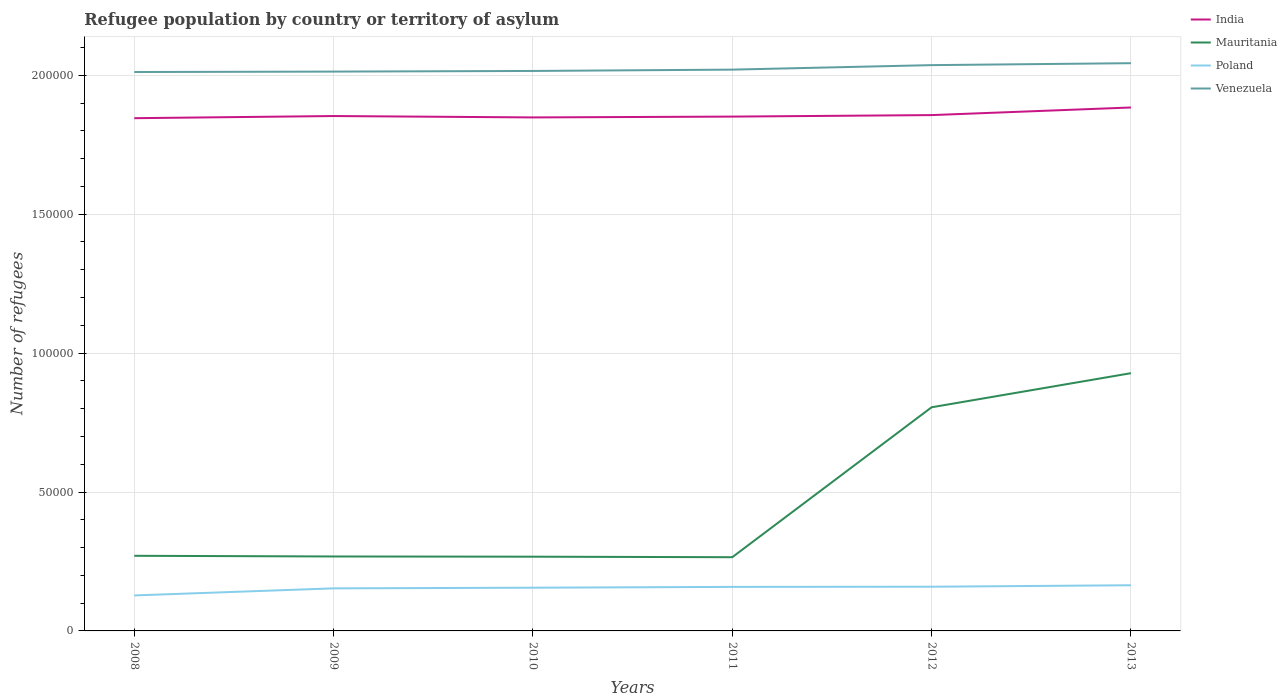How many different coloured lines are there?
Your response must be concise. 4. Is the number of lines equal to the number of legend labels?
Provide a succinct answer. Yes. Across all years, what is the maximum number of refugees in Poland?
Ensure brevity in your answer.  1.28e+04. What is the total number of refugees in India in the graph?
Offer a terse response. -278. What is the difference between the highest and the second highest number of refugees in Venezuela?
Ensure brevity in your answer.  3179. How many years are there in the graph?
Ensure brevity in your answer.  6. Does the graph contain any zero values?
Offer a terse response. No. Where does the legend appear in the graph?
Provide a short and direct response. Top right. How many legend labels are there?
Ensure brevity in your answer.  4. How are the legend labels stacked?
Make the answer very short. Vertical. What is the title of the graph?
Ensure brevity in your answer.  Refugee population by country or territory of asylum. What is the label or title of the Y-axis?
Keep it short and to the point. Number of refugees. What is the Number of refugees of India in 2008?
Provide a succinct answer. 1.85e+05. What is the Number of refugees of Mauritania in 2008?
Keep it short and to the point. 2.70e+04. What is the Number of refugees in Poland in 2008?
Keep it short and to the point. 1.28e+04. What is the Number of refugees of Venezuela in 2008?
Provide a short and direct response. 2.01e+05. What is the Number of refugees of India in 2009?
Make the answer very short. 1.85e+05. What is the Number of refugees of Mauritania in 2009?
Your response must be concise. 2.68e+04. What is the Number of refugees of Poland in 2009?
Provide a short and direct response. 1.53e+04. What is the Number of refugees of Venezuela in 2009?
Keep it short and to the point. 2.01e+05. What is the Number of refugees in India in 2010?
Keep it short and to the point. 1.85e+05. What is the Number of refugees in Mauritania in 2010?
Offer a terse response. 2.67e+04. What is the Number of refugees of Poland in 2010?
Your answer should be compact. 1.56e+04. What is the Number of refugees of Venezuela in 2010?
Give a very brief answer. 2.02e+05. What is the Number of refugees of India in 2011?
Offer a very short reply. 1.85e+05. What is the Number of refugees of Mauritania in 2011?
Keep it short and to the point. 2.65e+04. What is the Number of refugees of Poland in 2011?
Offer a terse response. 1.58e+04. What is the Number of refugees in Venezuela in 2011?
Ensure brevity in your answer.  2.02e+05. What is the Number of refugees in India in 2012?
Provide a short and direct response. 1.86e+05. What is the Number of refugees in Mauritania in 2012?
Keep it short and to the point. 8.05e+04. What is the Number of refugees in Poland in 2012?
Make the answer very short. 1.59e+04. What is the Number of refugees in Venezuela in 2012?
Keep it short and to the point. 2.04e+05. What is the Number of refugees in India in 2013?
Your answer should be very brief. 1.88e+05. What is the Number of refugees in Mauritania in 2013?
Give a very brief answer. 9.28e+04. What is the Number of refugees of Poland in 2013?
Make the answer very short. 1.64e+04. What is the Number of refugees in Venezuela in 2013?
Offer a very short reply. 2.04e+05. Across all years, what is the maximum Number of refugees in India?
Ensure brevity in your answer.  1.88e+05. Across all years, what is the maximum Number of refugees of Mauritania?
Your answer should be compact. 9.28e+04. Across all years, what is the maximum Number of refugees in Poland?
Your answer should be very brief. 1.64e+04. Across all years, what is the maximum Number of refugees in Venezuela?
Ensure brevity in your answer.  2.04e+05. Across all years, what is the minimum Number of refugees of India?
Provide a succinct answer. 1.85e+05. Across all years, what is the minimum Number of refugees in Mauritania?
Provide a succinct answer. 2.65e+04. Across all years, what is the minimum Number of refugees in Poland?
Keep it short and to the point. 1.28e+04. Across all years, what is the minimum Number of refugees in Venezuela?
Your response must be concise. 2.01e+05. What is the total Number of refugees in India in the graph?
Keep it short and to the point. 1.11e+06. What is the total Number of refugees in Mauritania in the graph?
Offer a terse response. 2.80e+05. What is the total Number of refugees of Poland in the graph?
Your answer should be very brief. 9.18e+04. What is the total Number of refugees in Venezuela in the graph?
Your answer should be very brief. 1.21e+06. What is the difference between the Number of refugees of India in 2008 and that in 2009?
Ensure brevity in your answer.  -780. What is the difference between the Number of refugees in Mauritania in 2008 and that in 2009?
Offer a very short reply. 246. What is the difference between the Number of refugees in Poland in 2008 and that in 2009?
Ensure brevity in your answer.  -2546. What is the difference between the Number of refugees of Venezuela in 2008 and that in 2009?
Offer a very short reply. -152. What is the difference between the Number of refugees of India in 2008 and that in 2010?
Ensure brevity in your answer.  -278. What is the difference between the Number of refugees in Mauritania in 2008 and that in 2010?
Provide a succinct answer. 324. What is the difference between the Number of refugees in Poland in 2008 and that in 2010?
Provide a succinct answer. -2781. What is the difference between the Number of refugees of Venezuela in 2008 and that in 2010?
Your answer should be compact. -386. What is the difference between the Number of refugees of India in 2008 and that in 2011?
Provide a short and direct response. -575. What is the difference between the Number of refugees in Mauritania in 2008 and that in 2011?
Your response must be concise. 506. What is the difference between the Number of refugees of Poland in 2008 and that in 2011?
Your response must be concise. -3073. What is the difference between the Number of refugees of Venezuela in 2008 and that in 2011?
Provide a succinct answer. -861. What is the difference between the Number of refugees of India in 2008 and that in 2012?
Provide a short and direct response. -1113. What is the difference between the Number of refugees of Mauritania in 2008 and that in 2012?
Give a very brief answer. -5.35e+04. What is the difference between the Number of refugees in Poland in 2008 and that in 2012?
Make the answer very short. -3137. What is the difference between the Number of refugees of Venezuela in 2008 and that in 2012?
Keep it short and to the point. -2483. What is the difference between the Number of refugees in India in 2008 and that in 2013?
Keep it short and to the point. -3852. What is the difference between the Number of refugees in Mauritania in 2008 and that in 2013?
Keep it short and to the point. -6.57e+04. What is the difference between the Number of refugees of Poland in 2008 and that in 2013?
Keep it short and to the point. -3664. What is the difference between the Number of refugees in Venezuela in 2008 and that in 2013?
Offer a very short reply. -3179. What is the difference between the Number of refugees of India in 2009 and that in 2010?
Provide a succinct answer. 502. What is the difference between the Number of refugees of Mauritania in 2009 and that in 2010?
Your answer should be compact. 78. What is the difference between the Number of refugees of Poland in 2009 and that in 2010?
Offer a terse response. -235. What is the difference between the Number of refugees of Venezuela in 2009 and that in 2010?
Your response must be concise. -234. What is the difference between the Number of refugees in India in 2009 and that in 2011?
Make the answer very short. 205. What is the difference between the Number of refugees in Mauritania in 2009 and that in 2011?
Offer a terse response. 260. What is the difference between the Number of refugees in Poland in 2009 and that in 2011?
Offer a very short reply. -527. What is the difference between the Number of refugees in Venezuela in 2009 and that in 2011?
Offer a very short reply. -709. What is the difference between the Number of refugees in India in 2009 and that in 2012?
Keep it short and to the point. -333. What is the difference between the Number of refugees of Mauritania in 2009 and that in 2012?
Provide a succinct answer. -5.37e+04. What is the difference between the Number of refugees in Poland in 2009 and that in 2012?
Offer a terse response. -591. What is the difference between the Number of refugees in Venezuela in 2009 and that in 2012?
Make the answer very short. -2331. What is the difference between the Number of refugees of India in 2009 and that in 2013?
Offer a very short reply. -3072. What is the difference between the Number of refugees of Mauritania in 2009 and that in 2013?
Offer a very short reply. -6.60e+04. What is the difference between the Number of refugees of Poland in 2009 and that in 2013?
Offer a terse response. -1118. What is the difference between the Number of refugees in Venezuela in 2009 and that in 2013?
Your response must be concise. -3027. What is the difference between the Number of refugees of India in 2010 and that in 2011?
Your answer should be compact. -297. What is the difference between the Number of refugees in Mauritania in 2010 and that in 2011?
Make the answer very short. 182. What is the difference between the Number of refugees in Poland in 2010 and that in 2011?
Your answer should be very brief. -292. What is the difference between the Number of refugees of Venezuela in 2010 and that in 2011?
Give a very brief answer. -475. What is the difference between the Number of refugees in India in 2010 and that in 2012?
Offer a very short reply. -835. What is the difference between the Number of refugees of Mauritania in 2010 and that in 2012?
Ensure brevity in your answer.  -5.38e+04. What is the difference between the Number of refugees of Poland in 2010 and that in 2012?
Provide a succinct answer. -356. What is the difference between the Number of refugees in Venezuela in 2010 and that in 2012?
Give a very brief answer. -2097. What is the difference between the Number of refugees of India in 2010 and that in 2013?
Give a very brief answer. -3574. What is the difference between the Number of refugees in Mauritania in 2010 and that in 2013?
Keep it short and to the point. -6.60e+04. What is the difference between the Number of refugees in Poland in 2010 and that in 2013?
Your answer should be very brief. -883. What is the difference between the Number of refugees in Venezuela in 2010 and that in 2013?
Your answer should be compact. -2793. What is the difference between the Number of refugees in India in 2011 and that in 2012?
Your response must be concise. -538. What is the difference between the Number of refugees in Mauritania in 2011 and that in 2012?
Offer a terse response. -5.40e+04. What is the difference between the Number of refugees in Poland in 2011 and that in 2012?
Keep it short and to the point. -64. What is the difference between the Number of refugees of Venezuela in 2011 and that in 2012?
Provide a succinct answer. -1622. What is the difference between the Number of refugees in India in 2011 and that in 2013?
Your response must be concise. -3277. What is the difference between the Number of refugees in Mauritania in 2011 and that in 2013?
Provide a short and direct response. -6.62e+04. What is the difference between the Number of refugees in Poland in 2011 and that in 2013?
Ensure brevity in your answer.  -591. What is the difference between the Number of refugees of Venezuela in 2011 and that in 2013?
Give a very brief answer. -2318. What is the difference between the Number of refugees in India in 2012 and that in 2013?
Give a very brief answer. -2739. What is the difference between the Number of refugees of Mauritania in 2012 and that in 2013?
Give a very brief answer. -1.23e+04. What is the difference between the Number of refugees of Poland in 2012 and that in 2013?
Ensure brevity in your answer.  -527. What is the difference between the Number of refugees of Venezuela in 2012 and that in 2013?
Offer a terse response. -696. What is the difference between the Number of refugees of India in 2008 and the Number of refugees of Mauritania in 2009?
Provide a succinct answer. 1.58e+05. What is the difference between the Number of refugees in India in 2008 and the Number of refugees in Poland in 2009?
Offer a terse response. 1.69e+05. What is the difference between the Number of refugees in India in 2008 and the Number of refugees in Venezuela in 2009?
Make the answer very short. -1.68e+04. What is the difference between the Number of refugees of Mauritania in 2008 and the Number of refugees of Poland in 2009?
Give a very brief answer. 1.17e+04. What is the difference between the Number of refugees in Mauritania in 2008 and the Number of refugees in Venezuela in 2009?
Your response must be concise. -1.74e+05. What is the difference between the Number of refugees of Poland in 2008 and the Number of refugees of Venezuela in 2009?
Offer a very short reply. -1.89e+05. What is the difference between the Number of refugees of India in 2008 and the Number of refugees of Mauritania in 2010?
Your answer should be very brief. 1.58e+05. What is the difference between the Number of refugees of India in 2008 and the Number of refugees of Poland in 2010?
Your answer should be compact. 1.69e+05. What is the difference between the Number of refugees of India in 2008 and the Number of refugees of Venezuela in 2010?
Give a very brief answer. -1.70e+04. What is the difference between the Number of refugees of Mauritania in 2008 and the Number of refugees of Poland in 2010?
Provide a short and direct response. 1.15e+04. What is the difference between the Number of refugees in Mauritania in 2008 and the Number of refugees in Venezuela in 2010?
Your answer should be compact. -1.75e+05. What is the difference between the Number of refugees of Poland in 2008 and the Number of refugees of Venezuela in 2010?
Keep it short and to the point. -1.89e+05. What is the difference between the Number of refugees of India in 2008 and the Number of refugees of Mauritania in 2011?
Give a very brief answer. 1.58e+05. What is the difference between the Number of refugees in India in 2008 and the Number of refugees in Poland in 2011?
Ensure brevity in your answer.  1.69e+05. What is the difference between the Number of refugees in India in 2008 and the Number of refugees in Venezuela in 2011?
Offer a very short reply. -1.75e+04. What is the difference between the Number of refugees in Mauritania in 2008 and the Number of refugees in Poland in 2011?
Ensure brevity in your answer.  1.12e+04. What is the difference between the Number of refugees in Mauritania in 2008 and the Number of refugees in Venezuela in 2011?
Your response must be concise. -1.75e+05. What is the difference between the Number of refugees of Poland in 2008 and the Number of refugees of Venezuela in 2011?
Ensure brevity in your answer.  -1.89e+05. What is the difference between the Number of refugees of India in 2008 and the Number of refugees of Mauritania in 2012?
Provide a succinct answer. 1.04e+05. What is the difference between the Number of refugees of India in 2008 and the Number of refugees of Poland in 2012?
Keep it short and to the point. 1.69e+05. What is the difference between the Number of refugees of India in 2008 and the Number of refugees of Venezuela in 2012?
Your answer should be compact. -1.91e+04. What is the difference between the Number of refugees in Mauritania in 2008 and the Number of refugees in Poland in 2012?
Your answer should be very brief. 1.11e+04. What is the difference between the Number of refugees in Mauritania in 2008 and the Number of refugees in Venezuela in 2012?
Your answer should be very brief. -1.77e+05. What is the difference between the Number of refugees of Poland in 2008 and the Number of refugees of Venezuela in 2012?
Make the answer very short. -1.91e+05. What is the difference between the Number of refugees of India in 2008 and the Number of refugees of Mauritania in 2013?
Offer a terse response. 9.18e+04. What is the difference between the Number of refugees of India in 2008 and the Number of refugees of Poland in 2013?
Ensure brevity in your answer.  1.68e+05. What is the difference between the Number of refugees in India in 2008 and the Number of refugees in Venezuela in 2013?
Provide a succinct answer. -1.98e+04. What is the difference between the Number of refugees of Mauritania in 2008 and the Number of refugees of Poland in 2013?
Your answer should be very brief. 1.06e+04. What is the difference between the Number of refugees in Mauritania in 2008 and the Number of refugees in Venezuela in 2013?
Offer a terse response. -1.77e+05. What is the difference between the Number of refugees in Poland in 2008 and the Number of refugees in Venezuela in 2013?
Keep it short and to the point. -1.92e+05. What is the difference between the Number of refugees in India in 2009 and the Number of refugees in Mauritania in 2010?
Give a very brief answer. 1.59e+05. What is the difference between the Number of refugees in India in 2009 and the Number of refugees in Poland in 2010?
Keep it short and to the point. 1.70e+05. What is the difference between the Number of refugees of India in 2009 and the Number of refugees of Venezuela in 2010?
Provide a succinct answer. -1.62e+04. What is the difference between the Number of refugees of Mauritania in 2009 and the Number of refugees of Poland in 2010?
Your answer should be compact. 1.12e+04. What is the difference between the Number of refugees in Mauritania in 2009 and the Number of refugees in Venezuela in 2010?
Give a very brief answer. -1.75e+05. What is the difference between the Number of refugees in Poland in 2009 and the Number of refugees in Venezuela in 2010?
Offer a very short reply. -1.86e+05. What is the difference between the Number of refugees of India in 2009 and the Number of refugees of Mauritania in 2011?
Offer a terse response. 1.59e+05. What is the difference between the Number of refugees in India in 2009 and the Number of refugees in Poland in 2011?
Provide a short and direct response. 1.69e+05. What is the difference between the Number of refugees in India in 2009 and the Number of refugees in Venezuela in 2011?
Provide a succinct answer. -1.67e+04. What is the difference between the Number of refugees in Mauritania in 2009 and the Number of refugees in Poland in 2011?
Ensure brevity in your answer.  1.09e+04. What is the difference between the Number of refugees in Mauritania in 2009 and the Number of refugees in Venezuela in 2011?
Your answer should be compact. -1.75e+05. What is the difference between the Number of refugees of Poland in 2009 and the Number of refugees of Venezuela in 2011?
Provide a succinct answer. -1.87e+05. What is the difference between the Number of refugees of India in 2009 and the Number of refugees of Mauritania in 2012?
Your answer should be very brief. 1.05e+05. What is the difference between the Number of refugees of India in 2009 and the Number of refugees of Poland in 2012?
Make the answer very short. 1.69e+05. What is the difference between the Number of refugees in India in 2009 and the Number of refugees in Venezuela in 2012?
Keep it short and to the point. -1.83e+04. What is the difference between the Number of refugees of Mauritania in 2009 and the Number of refugees of Poland in 2012?
Keep it short and to the point. 1.09e+04. What is the difference between the Number of refugees in Mauritania in 2009 and the Number of refugees in Venezuela in 2012?
Your response must be concise. -1.77e+05. What is the difference between the Number of refugees in Poland in 2009 and the Number of refugees in Venezuela in 2012?
Offer a terse response. -1.88e+05. What is the difference between the Number of refugees in India in 2009 and the Number of refugees in Mauritania in 2013?
Offer a terse response. 9.26e+04. What is the difference between the Number of refugees in India in 2009 and the Number of refugees in Poland in 2013?
Give a very brief answer. 1.69e+05. What is the difference between the Number of refugees in India in 2009 and the Number of refugees in Venezuela in 2013?
Ensure brevity in your answer.  -1.90e+04. What is the difference between the Number of refugees of Mauritania in 2009 and the Number of refugees of Poland in 2013?
Your answer should be compact. 1.04e+04. What is the difference between the Number of refugees of Mauritania in 2009 and the Number of refugees of Venezuela in 2013?
Your answer should be compact. -1.78e+05. What is the difference between the Number of refugees of Poland in 2009 and the Number of refugees of Venezuela in 2013?
Keep it short and to the point. -1.89e+05. What is the difference between the Number of refugees of India in 2010 and the Number of refugees of Mauritania in 2011?
Provide a succinct answer. 1.58e+05. What is the difference between the Number of refugees of India in 2010 and the Number of refugees of Poland in 2011?
Offer a terse response. 1.69e+05. What is the difference between the Number of refugees of India in 2010 and the Number of refugees of Venezuela in 2011?
Your response must be concise. -1.72e+04. What is the difference between the Number of refugees in Mauritania in 2010 and the Number of refugees in Poland in 2011?
Your answer should be compact. 1.09e+04. What is the difference between the Number of refugees of Mauritania in 2010 and the Number of refugees of Venezuela in 2011?
Provide a succinct answer. -1.75e+05. What is the difference between the Number of refugees in Poland in 2010 and the Number of refugees in Venezuela in 2011?
Provide a succinct answer. -1.86e+05. What is the difference between the Number of refugees of India in 2010 and the Number of refugees of Mauritania in 2012?
Give a very brief answer. 1.04e+05. What is the difference between the Number of refugees of India in 2010 and the Number of refugees of Poland in 2012?
Offer a terse response. 1.69e+05. What is the difference between the Number of refugees in India in 2010 and the Number of refugees in Venezuela in 2012?
Offer a terse response. -1.88e+04. What is the difference between the Number of refugees in Mauritania in 2010 and the Number of refugees in Poland in 2012?
Give a very brief answer. 1.08e+04. What is the difference between the Number of refugees of Mauritania in 2010 and the Number of refugees of Venezuela in 2012?
Your answer should be compact. -1.77e+05. What is the difference between the Number of refugees in Poland in 2010 and the Number of refugees in Venezuela in 2012?
Your response must be concise. -1.88e+05. What is the difference between the Number of refugees of India in 2010 and the Number of refugees of Mauritania in 2013?
Your response must be concise. 9.21e+04. What is the difference between the Number of refugees of India in 2010 and the Number of refugees of Poland in 2013?
Keep it short and to the point. 1.68e+05. What is the difference between the Number of refugees of India in 2010 and the Number of refugees of Venezuela in 2013?
Give a very brief answer. -1.95e+04. What is the difference between the Number of refugees in Mauritania in 2010 and the Number of refugees in Poland in 2013?
Give a very brief answer. 1.03e+04. What is the difference between the Number of refugees in Mauritania in 2010 and the Number of refugees in Venezuela in 2013?
Your response must be concise. -1.78e+05. What is the difference between the Number of refugees in Poland in 2010 and the Number of refugees in Venezuela in 2013?
Offer a very short reply. -1.89e+05. What is the difference between the Number of refugees in India in 2011 and the Number of refugees in Mauritania in 2012?
Your answer should be very brief. 1.05e+05. What is the difference between the Number of refugees in India in 2011 and the Number of refugees in Poland in 2012?
Make the answer very short. 1.69e+05. What is the difference between the Number of refugees in India in 2011 and the Number of refugees in Venezuela in 2012?
Make the answer very short. -1.85e+04. What is the difference between the Number of refugees of Mauritania in 2011 and the Number of refugees of Poland in 2012?
Your answer should be very brief. 1.06e+04. What is the difference between the Number of refugees of Mauritania in 2011 and the Number of refugees of Venezuela in 2012?
Provide a short and direct response. -1.77e+05. What is the difference between the Number of refugees of Poland in 2011 and the Number of refugees of Venezuela in 2012?
Offer a terse response. -1.88e+05. What is the difference between the Number of refugees in India in 2011 and the Number of refugees in Mauritania in 2013?
Ensure brevity in your answer.  9.24e+04. What is the difference between the Number of refugees in India in 2011 and the Number of refugees in Poland in 2013?
Your answer should be very brief. 1.69e+05. What is the difference between the Number of refugees of India in 2011 and the Number of refugees of Venezuela in 2013?
Provide a succinct answer. -1.92e+04. What is the difference between the Number of refugees in Mauritania in 2011 and the Number of refugees in Poland in 2013?
Your answer should be compact. 1.01e+04. What is the difference between the Number of refugees of Mauritania in 2011 and the Number of refugees of Venezuela in 2013?
Provide a succinct answer. -1.78e+05. What is the difference between the Number of refugees of Poland in 2011 and the Number of refugees of Venezuela in 2013?
Your answer should be compact. -1.88e+05. What is the difference between the Number of refugees in India in 2012 and the Number of refugees in Mauritania in 2013?
Offer a terse response. 9.29e+04. What is the difference between the Number of refugees of India in 2012 and the Number of refugees of Poland in 2013?
Offer a terse response. 1.69e+05. What is the difference between the Number of refugees in India in 2012 and the Number of refugees in Venezuela in 2013?
Keep it short and to the point. -1.87e+04. What is the difference between the Number of refugees in Mauritania in 2012 and the Number of refugees in Poland in 2013?
Provide a succinct answer. 6.41e+04. What is the difference between the Number of refugees of Mauritania in 2012 and the Number of refugees of Venezuela in 2013?
Your response must be concise. -1.24e+05. What is the difference between the Number of refugees of Poland in 2012 and the Number of refugees of Venezuela in 2013?
Keep it short and to the point. -1.88e+05. What is the average Number of refugees of India per year?
Your response must be concise. 1.86e+05. What is the average Number of refugees of Mauritania per year?
Offer a terse response. 4.67e+04. What is the average Number of refugees in Poland per year?
Give a very brief answer. 1.53e+04. What is the average Number of refugees of Venezuela per year?
Your answer should be compact. 2.02e+05. In the year 2008, what is the difference between the Number of refugees in India and Number of refugees in Mauritania?
Offer a terse response. 1.58e+05. In the year 2008, what is the difference between the Number of refugees of India and Number of refugees of Poland?
Offer a very short reply. 1.72e+05. In the year 2008, what is the difference between the Number of refugees in India and Number of refugees in Venezuela?
Provide a succinct answer. -1.66e+04. In the year 2008, what is the difference between the Number of refugees in Mauritania and Number of refugees in Poland?
Offer a terse response. 1.43e+04. In the year 2008, what is the difference between the Number of refugees of Mauritania and Number of refugees of Venezuela?
Give a very brief answer. -1.74e+05. In the year 2008, what is the difference between the Number of refugees of Poland and Number of refugees of Venezuela?
Your response must be concise. -1.88e+05. In the year 2009, what is the difference between the Number of refugees in India and Number of refugees in Mauritania?
Provide a succinct answer. 1.59e+05. In the year 2009, what is the difference between the Number of refugees in India and Number of refugees in Poland?
Your answer should be very brief. 1.70e+05. In the year 2009, what is the difference between the Number of refugees in India and Number of refugees in Venezuela?
Provide a succinct answer. -1.60e+04. In the year 2009, what is the difference between the Number of refugees of Mauritania and Number of refugees of Poland?
Offer a very short reply. 1.15e+04. In the year 2009, what is the difference between the Number of refugees of Mauritania and Number of refugees of Venezuela?
Your answer should be very brief. -1.75e+05. In the year 2009, what is the difference between the Number of refugees in Poland and Number of refugees in Venezuela?
Your response must be concise. -1.86e+05. In the year 2010, what is the difference between the Number of refugees in India and Number of refugees in Mauritania?
Keep it short and to the point. 1.58e+05. In the year 2010, what is the difference between the Number of refugees of India and Number of refugees of Poland?
Offer a very short reply. 1.69e+05. In the year 2010, what is the difference between the Number of refugees of India and Number of refugees of Venezuela?
Offer a terse response. -1.67e+04. In the year 2010, what is the difference between the Number of refugees in Mauritania and Number of refugees in Poland?
Keep it short and to the point. 1.12e+04. In the year 2010, what is the difference between the Number of refugees of Mauritania and Number of refugees of Venezuela?
Make the answer very short. -1.75e+05. In the year 2010, what is the difference between the Number of refugees in Poland and Number of refugees in Venezuela?
Make the answer very short. -1.86e+05. In the year 2011, what is the difference between the Number of refugees of India and Number of refugees of Mauritania?
Offer a very short reply. 1.59e+05. In the year 2011, what is the difference between the Number of refugees of India and Number of refugees of Poland?
Your response must be concise. 1.69e+05. In the year 2011, what is the difference between the Number of refugees of India and Number of refugees of Venezuela?
Provide a succinct answer. -1.69e+04. In the year 2011, what is the difference between the Number of refugees in Mauritania and Number of refugees in Poland?
Your answer should be very brief. 1.07e+04. In the year 2011, what is the difference between the Number of refugees of Mauritania and Number of refugees of Venezuela?
Your answer should be compact. -1.75e+05. In the year 2011, what is the difference between the Number of refugees in Poland and Number of refugees in Venezuela?
Your answer should be compact. -1.86e+05. In the year 2012, what is the difference between the Number of refugees in India and Number of refugees in Mauritania?
Ensure brevity in your answer.  1.05e+05. In the year 2012, what is the difference between the Number of refugees in India and Number of refugees in Poland?
Your response must be concise. 1.70e+05. In the year 2012, what is the difference between the Number of refugees in India and Number of refugees in Venezuela?
Give a very brief answer. -1.80e+04. In the year 2012, what is the difference between the Number of refugees in Mauritania and Number of refugees in Poland?
Provide a succinct answer. 6.46e+04. In the year 2012, what is the difference between the Number of refugees of Mauritania and Number of refugees of Venezuela?
Provide a succinct answer. -1.23e+05. In the year 2012, what is the difference between the Number of refugees in Poland and Number of refugees in Venezuela?
Keep it short and to the point. -1.88e+05. In the year 2013, what is the difference between the Number of refugees of India and Number of refugees of Mauritania?
Provide a short and direct response. 9.56e+04. In the year 2013, what is the difference between the Number of refugees of India and Number of refugees of Poland?
Provide a succinct answer. 1.72e+05. In the year 2013, what is the difference between the Number of refugees in India and Number of refugees in Venezuela?
Make the answer very short. -1.59e+04. In the year 2013, what is the difference between the Number of refugees in Mauritania and Number of refugees in Poland?
Provide a succinct answer. 7.63e+04. In the year 2013, what is the difference between the Number of refugees in Mauritania and Number of refugees in Venezuela?
Your answer should be very brief. -1.12e+05. In the year 2013, what is the difference between the Number of refugees in Poland and Number of refugees in Venezuela?
Provide a short and direct response. -1.88e+05. What is the ratio of the Number of refugees in India in 2008 to that in 2009?
Provide a short and direct response. 1. What is the ratio of the Number of refugees in Mauritania in 2008 to that in 2009?
Make the answer very short. 1.01. What is the ratio of the Number of refugees of Poland in 2008 to that in 2009?
Provide a short and direct response. 0.83. What is the ratio of the Number of refugees in Mauritania in 2008 to that in 2010?
Provide a succinct answer. 1.01. What is the ratio of the Number of refugees in Poland in 2008 to that in 2010?
Offer a terse response. 0.82. What is the ratio of the Number of refugees in Venezuela in 2008 to that in 2010?
Your answer should be very brief. 1. What is the ratio of the Number of refugees in India in 2008 to that in 2011?
Offer a terse response. 1. What is the ratio of the Number of refugees of Mauritania in 2008 to that in 2011?
Your answer should be compact. 1.02. What is the ratio of the Number of refugees of Poland in 2008 to that in 2011?
Keep it short and to the point. 0.81. What is the ratio of the Number of refugees of Venezuela in 2008 to that in 2011?
Provide a short and direct response. 1. What is the ratio of the Number of refugees of Mauritania in 2008 to that in 2012?
Ensure brevity in your answer.  0.34. What is the ratio of the Number of refugees in Poland in 2008 to that in 2012?
Keep it short and to the point. 0.8. What is the ratio of the Number of refugees of Venezuela in 2008 to that in 2012?
Keep it short and to the point. 0.99. What is the ratio of the Number of refugees in India in 2008 to that in 2013?
Provide a succinct answer. 0.98. What is the ratio of the Number of refugees of Mauritania in 2008 to that in 2013?
Provide a succinct answer. 0.29. What is the ratio of the Number of refugees of Poland in 2008 to that in 2013?
Ensure brevity in your answer.  0.78. What is the ratio of the Number of refugees of Venezuela in 2008 to that in 2013?
Ensure brevity in your answer.  0.98. What is the ratio of the Number of refugees of India in 2009 to that in 2010?
Your answer should be compact. 1. What is the ratio of the Number of refugees in Mauritania in 2009 to that in 2010?
Offer a very short reply. 1. What is the ratio of the Number of refugees of Poland in 2009 to that in 2010?
Keep it short and to the point. 0.98. What is the ratio of the Number of refugees in Venezuela in 2009 to that in 2010?
Your response must be concise. 1. What is the ratio of the Number of refugees in India in 2009 to that in 2011?
Ensure brevity in your answer.  1. What is the ratio of the Number of refugees in Mauritania in 2009 to that in 2011?
Keep it short and to the point. 1.01. What is the ratio of the Number of refugees in Poland in 2009 to that in 2011?
Make the answer very short. 0.97. What is the ratio of the Number of refugees of India in 2009 to that in 2012?
Your answer should be very brief. 1. What is the ratio of the Number of refugees of Mauritania in 2009 to that in 2012?
Offer a terse response. 0.33. What is the ratio of the Number of refugees of Poland in 2009 to that in 2012?
Your answer should be compact. 0.96. What is the ratio of the Number of refugees of Venezuela in 2009 to that in 2012?
Make the answer very short. 0.99. What is the ratio of the Number of refugees of India in 2009 to that in 2013?
Provide a short and direct response. 0.98. What is the ratio of the Number of refugees in Mauritania in 2009 to that in 2013?
Your response must be concise. 0.29. What is the ratio of the Number of refugees in Poland in 2009 to that in 2013?
Offer a terse response. 0.93. What is the ratio of the Number of refugees in Venezuela in 2009 to that in 2013?
Give a very brief answer. 0.99. What is the ratio of the Number of refugees in Mauritania in 2010 to that in 2011?
Give a very brief answer. 1.01. What is the ratio of the Number of refugees in Poland in 2010 to that in 2011?
Give a very brief answer. 0.98. What is the ratio of the Number of refugees in Venezuela in 2010 to that in 2011?
Provide a short and direct response. 1. What is the ratio of the Number of refugees in India in 2010 to that in 2012?
Offer a very short reply. 1. What is the ratio of the Number of refugees in Mauritania in 2010 to that in 2012?
Your answer should be very brief. 0.33. What is the ratio of the Number of refugees in Poland in 2010 to that in 2012?
Provide a succinct answer. 0.98. What is the ratio of the Number of refugees of Mauritania in 2010 to that in 2013?
Your answer should be very brief. 0.29. What is the ratio of the Number of refugees of Poland in 2010 to that in 2013?
Your response must be concise. 0.95. What is the ratio of the Number of refugees in Venezuela in 2010 to that in 2013?
Offer a very short reply. 0.99. What is the ratio of the Number of refugees in Mauritania in 2011 to that in 2012?
Make the answer very short. 0.33. What is the ratio of the Number of refugees in Venezuela in 2011 to that in 2012?
Provide a succinct answer. 0.99. What is the ratio of the Number of refugees in India in 2011 to that in 2013?
Ensure brevity in your answer.  0.98. What is the ratio of the Number of refugees in Mauritania in 2011 to that in 2013?
Your response must be concise. 0.29. What is the ratio of the Number of refugees in Poland in 2011 to that in 2013?
Provide a succinct answer. 0.96. What is the ratio of the Number of refugees of Venezuela in 2011 to that in 2013?
Your response must be concise. 0.99. What is the ratio of the Number of refugees in India in 2012 to that in 2013?
Your answer should be compact. 0.99. What is the ratio of the Number of refugees in Mauritania in 2012 to that in 2013?
Your response must be concise. 0.87. What is the ratio of the Number of refugees in Poland in 2012 to that in 2013?
Keep it short and to the point. 0.97. What is the ratio of the Number of refugees of Venezuela in 2012 to that in 2013?
Your answer should be compact. 1. What is the difference between the highest and the second highest Number of refugees in India?
Ensure brevity in your answer.  2739. What is the difference between the highest and the second highest Number of refugees in Mauritania?
Your answer should be very brief. 1.23e+04. What is the difference between the highest and the second highest Number of refugees of Poland?
Offer a very short reply. 527. What is the difference between the highest and the second highest Number of refugees of Venezuela?
Your answer should be very brief. 696. What is the difference between the highest and the lowest Number of refugees of India?
Provide a succinct answer. 3852. What is the difference between the highest and the lowest Number of refugees in Mauritania?
Make the answer very short. 6.62e+04. What is the difference between the highest and the lowest Number of refugees of Poland?
Offer a very short reply. 3664. What is the difference between the highest and the lowest Number of refugees of Venezuela?
Provide a short and direct response. 3179. 